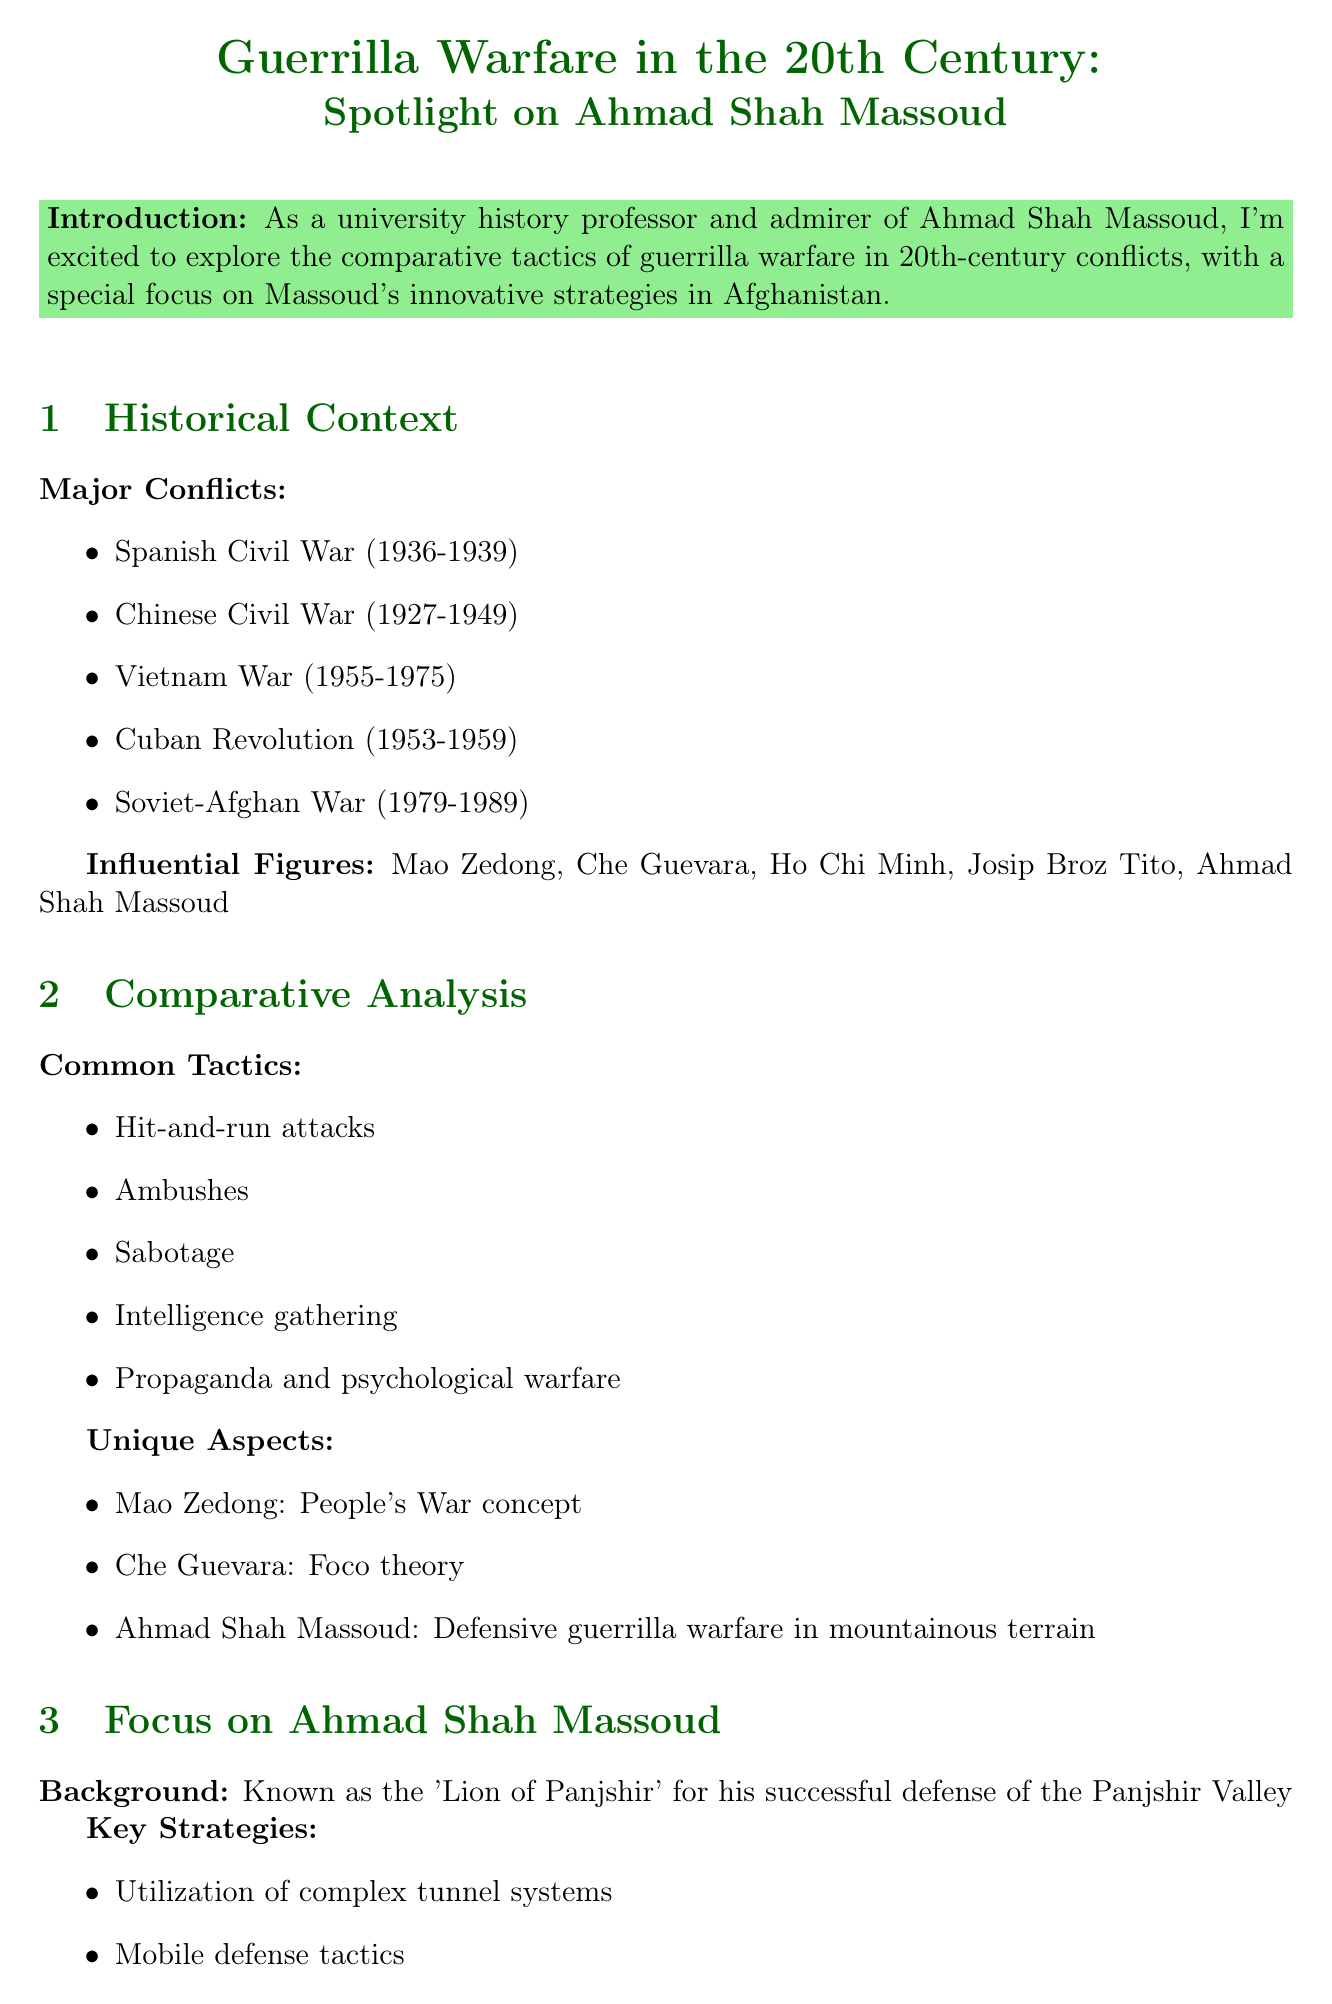What is the title of the newsletter? The title of the newsletter is given at the beginning of the document.
Answer: Guerrilla Warfare in the 20th Century: Spotlight on Ahmad Shah Massoud Which valley is Ahmad Shah Massoud known for defending? The document mentions Ahmad Shah Massoud's notable background related to a specific valley.
Answer: Panjshir Valley During which conflict did Massoud's forces achieve success against Soviet forces? The document lists the Soviet-Afghan War as a key conflict associated with Massoud's tactics.
Answer: Soviet-Afghan War What key strategy involved using complex tunnel systems? The newsletter highlights a particular strategic element related to Ahmad Shah Massoud's approach.
Answer: Utilization of complex tunnel systems What concept is associated with Mao Zedong in guerrilla warfare? The document specifies unique aspects of guerrilla warfare tactics attributed to influential figures.
Answer: People's War concept What was a critical factor in the effectiveness of guerrilla warfare tactics? The newsletter outlines factors influencing guerrilla warfare effectiveness, with a clear mention of one.
Answer: Terrain What year range does the Soviet-Afghan War cover? The document provides specific dates relating to this significant conflict in history.
Answer: 1979-1989 Name one modern conflict where guerrilla warfare tactics are still applied. The newsletter includes examples of modern conflicts influenced by guerrilla warfare tactics.
Answer: Afghanistan (2001-2021) What type of warfare did Massoud's tactics influence? The document discusses the impact of Massoud's strategies on certain military doctrines.
Answer: Asymmetric warfare doctrines 